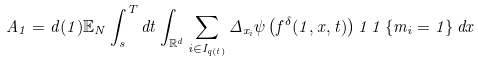Convert formula to latex. <formula><loc_0><loc_0><loc_500><loc_500>A _ { 1 } = d ( 1 ) \mathbb { E } _ { N } \int _ { s } ^ { T } d t \int _ { \mathbb { R } ^ { d } } \sum _ { i \in I _ { q ( t ) } } { \Delta _ { x _ { i } } \psi \left ( f ^ { \delta } ( 1 , x , t ) \right ) 1 \, 1 \left \{ m _ { i } = 1 \right \} d x }</formula> 